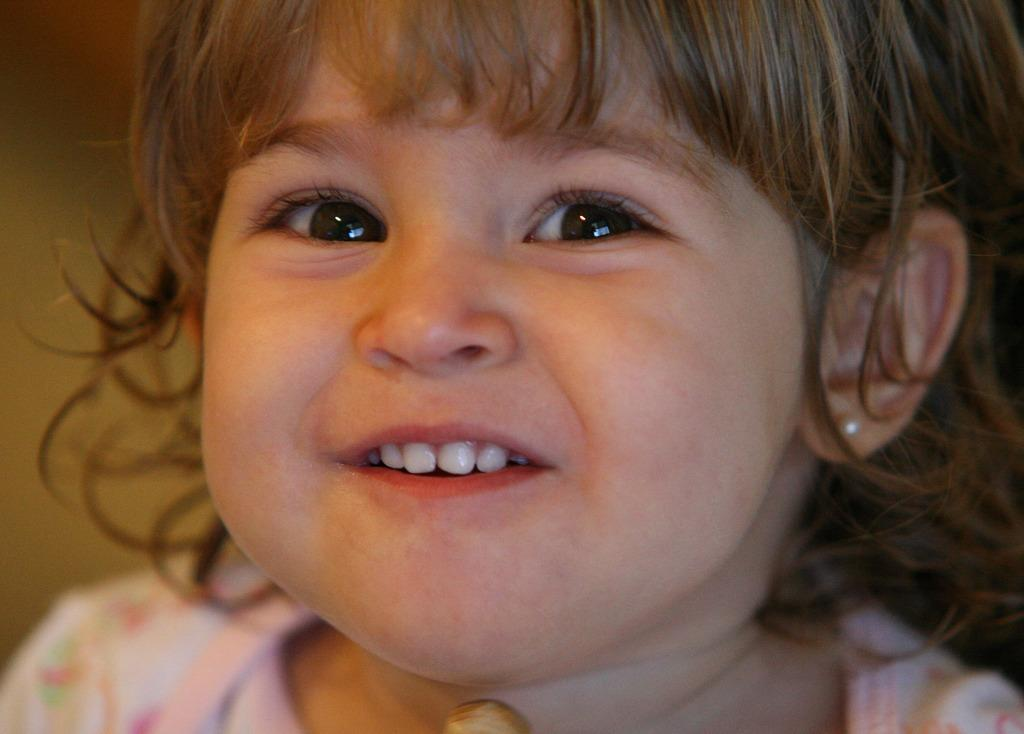What is the main subject of the image? There is a kid in the center of the image. How many apples are being used as an example by the robin in the image? There is no robin or apples present in the image; it features a kid in the center. 